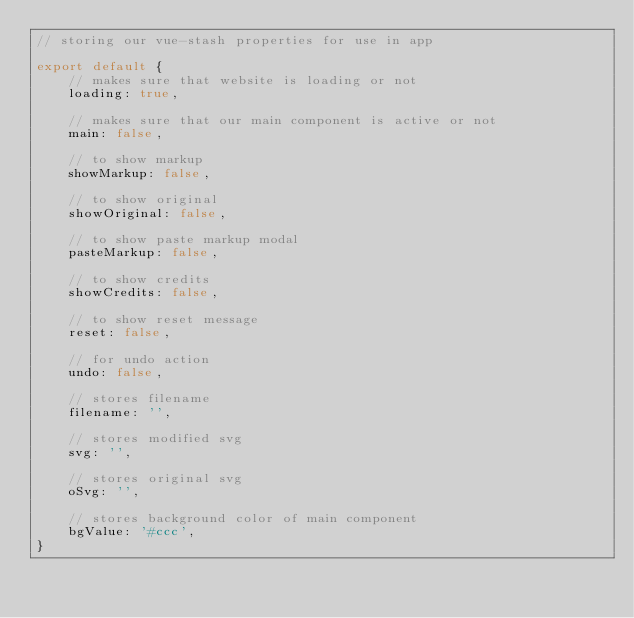<code> <loc_0><loc_0><loc_500><loc_500><_JavaScript_>// storing our vue-stash properties for use in app

export default {
    // makes sure that website is loading or not
    loading: true,

    // makes sure that our main component is active or not
    main: false,

    // to show markup
    showMarkup: false,

    // to show original
    showOriginal: false,

    // to show paste markup modal
    pasteMarkup: false,

    // to show credits
    showCredits: false,

    // to show reset message
    reset: false,

    // for undo action
    undo: false,

    // stores filename 
    filename: '',

    // stores modified svg
    svg: '',

    // stores original svg
    oSvg: '',

    // stores background color of main component
    bgValue: '#ccc',
}</code> 